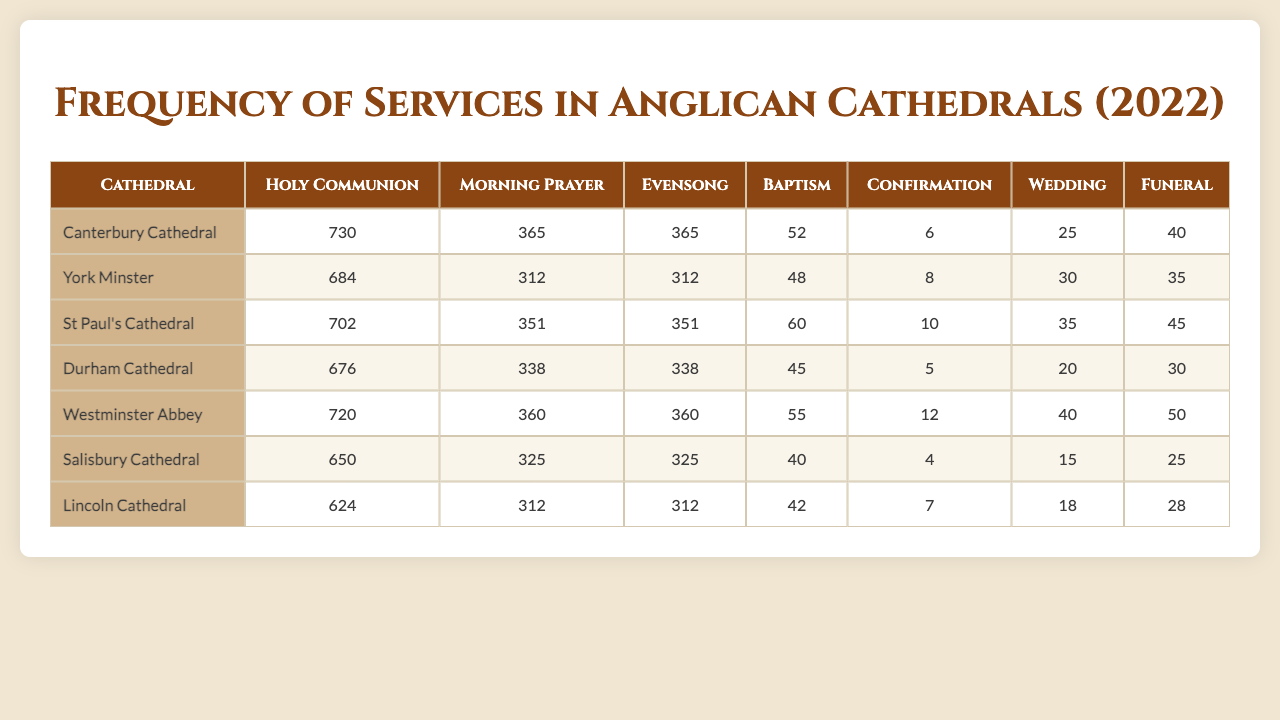What is the frequency of Holy Communion at Canterbury Cathedral? Referring to the table, the frequency of Holy Communion at Canterbury Cathedral is listed as 730.
Answer: 730 How many times is Evensong held at St Paul's Cathedral? The table indicates that Evensong occurs 351 times at St Paul's Cathedral.
Answer: 351 Which cathedral has the highest frequency of Weddings? By comparing the wedding frequencies across the table, Westminster Abbey has the highest frequency at 40.
Answer: Westminster Abbey What is the total frequency of Morning Prayer for all listed cathedrals? The frequencies of Morning Prayer are 365 (Canterbury), 312 (York), 351 (St Paul's), 338 (Durham), 360 (Westminster), 325 (Salisbury), and 312 (Lincoln). Adding them gives 365 + 312 + 351 + 338 + 360 + 325 + 312 = 2263.
Answer: 2263 Is it true that Lincoln Cathedral holds more Baptisms than Salisbury Cathedral? According to the table, Lincoln Cathedral has 42 Baptisms, while Salisbury Cathedral has 40 Baptisms, which confirms that Lincoln has more.
Answer: Yes What is the average frequency of Funerals across all cathedrals? The Funerals frequencies are 40 (Canterbury), 35 (York), 45 (St Paul's), 30 (Durham), 50 (Westminster), 25 (Salisbury), and 28 (Lincoln). The total is 40 + 35 + 45 + 30 + 50 + 25 + 28 = 253, and with 7 cathedrals, the average is 253 / 7 = approximately 36.14.
Answer: Approximately 36.14 Which cathedral has the lowest total frequency of all services combined? Calculating the total for each cathedral gives: Canterbury (2282), York (2079), St Paul's (2017), Durham (1847), Westminster (2017), Salisbury (1315), and Lincoln (1216). Lincoln Cathedral has the lowest total.
Answer: Lincoln Cathedral What is the difference in frequency of Weddings between Westminster Abbey and Durham Cathedral? Westminster Abbey has 40 Weddings, while Durham Cathedral has 20. The difference is 40 - 20 = 20.
Answer: 20 How many cathedrals have more than 300 funerals? Reviewing the frequencies, only St Paul's (45), Westminster Abbey (50), and Lincoln Cathedral (28) have more than 300 funerals, which totals to three cathedrals.
Answer: Three What service type is held the most frequently at York Minster? At York Minster, Holy Communion is the most frequent service with 684 occurrences.
Answer: Holy Communion 